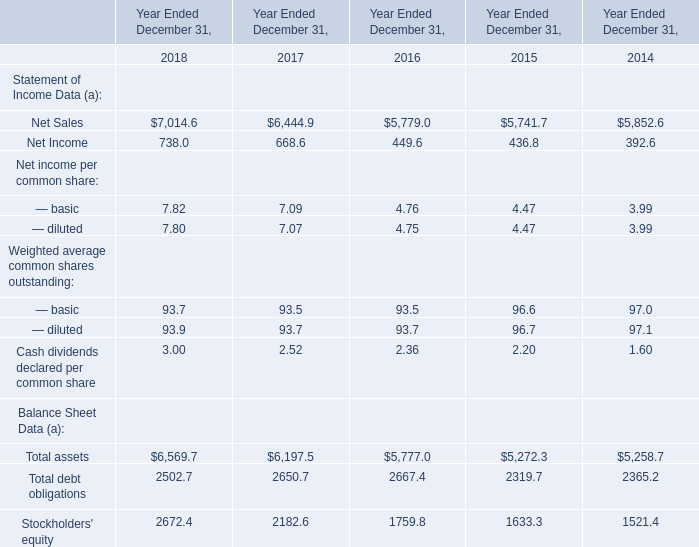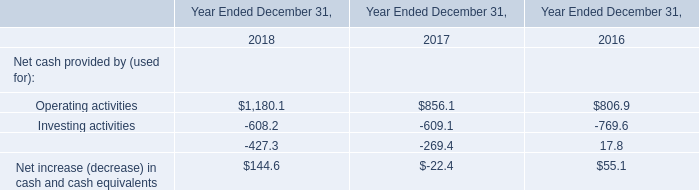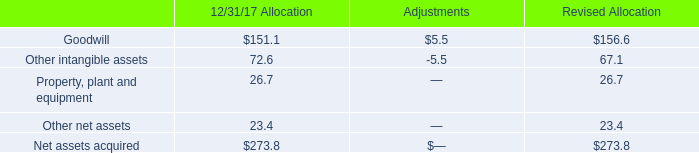What is the average amount of Operating activities of Year Ended December 31, 2018, and Net Sales of Year Ended December 31, 2017 ? 
Computations: ((1180.1 + 6444.9) / 2)
Answer: 3812.5. 